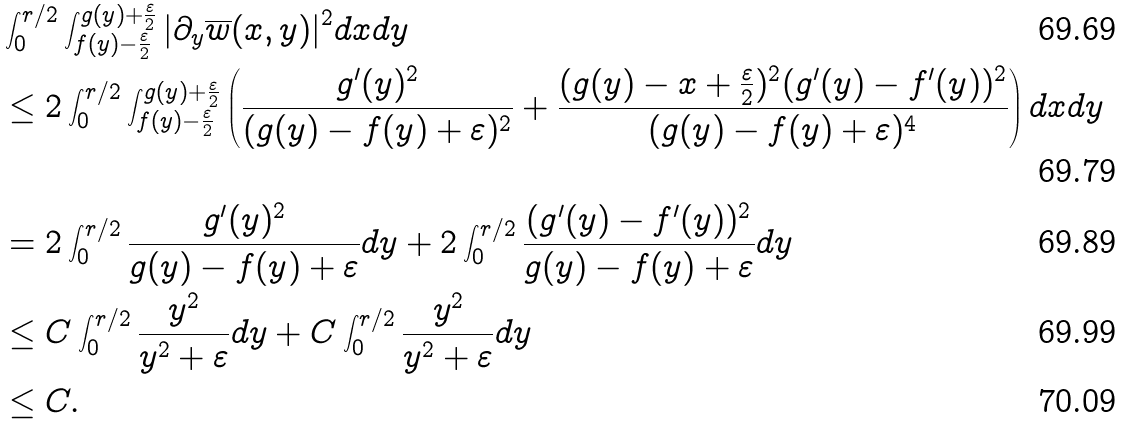<formula> <loc_0><loc_0><loc_500><loc_500>& \int ^ { r / 2 } _ { 0 } \int ^ { g ( y ) + \frac { \varepsilon } { 2 } } _ { f ( y ) - \frac { \varepsilon } { 2 } } | \partial _ { y } \overline { w } ( x , y ) | ^ { 2 } d x d y \\ & \leq 2 \int ^ { r / 2 } _ { 0 } \int ^ { g ( y ) + \frac { \varepsilon } { 2 } } _ { f ( y ) - \frac { \varepsilon } { 2 } } \left ( \frac { g ^ { \prime } ( y ) ^ { 2 } } { ( g ( y ) - f ( y ) + \varepsilon ) ^ { 2 } } + \frac { ( g ( y ) - x + \frac { \varepsilon } { 2 } ) ^ { 2 } ( g ^ { \prime } ( y ) - f ^ { \prime } ( y ) ) ^ { 2 } } { ( g ( y ) - f ( y ) + \varepsilon ) ^ { 4 } } \right ) d x d y \\ & = 2 \int ^ { r / 2 } _ { 0 } \frac { g ^ { \prime } ( y ) ^ { 2 } } { g ( y ) - f ( y ) + \varepsilon } d y + 2 \int ^ { r / 2 } _ { 0 } \frac { ( g ^ { \prime } ( y ) - f ^ { \prime } ( y ) ) ^ { 2 } } { g ( y ) - f ( y ) + \varepsilon } d y \\ & \leq C \int ^ { r / 2 } _ { 0 } \frac { y ^ { 2 } } { y ^ { 2 } + \varepsilon } d y + C \int ^ { r / 2 } _ { 0 } \frac { y ^ { 2 } } { y ^ { 2 } + \varepsilon } d y \\ & \leq C .</formula> 